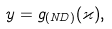Convert formula to latex. <formula><loc_0><loc_0><loc_500><loc_500>y = g _ { ( N D ) } ( \varkappa ) ,</formula> 